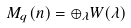<formula> <loc_0><loc_0><loc_500><loc_500>M _ { q } ( n ) = \oplus _ { \lambda } W ( \lambda )</formula> 